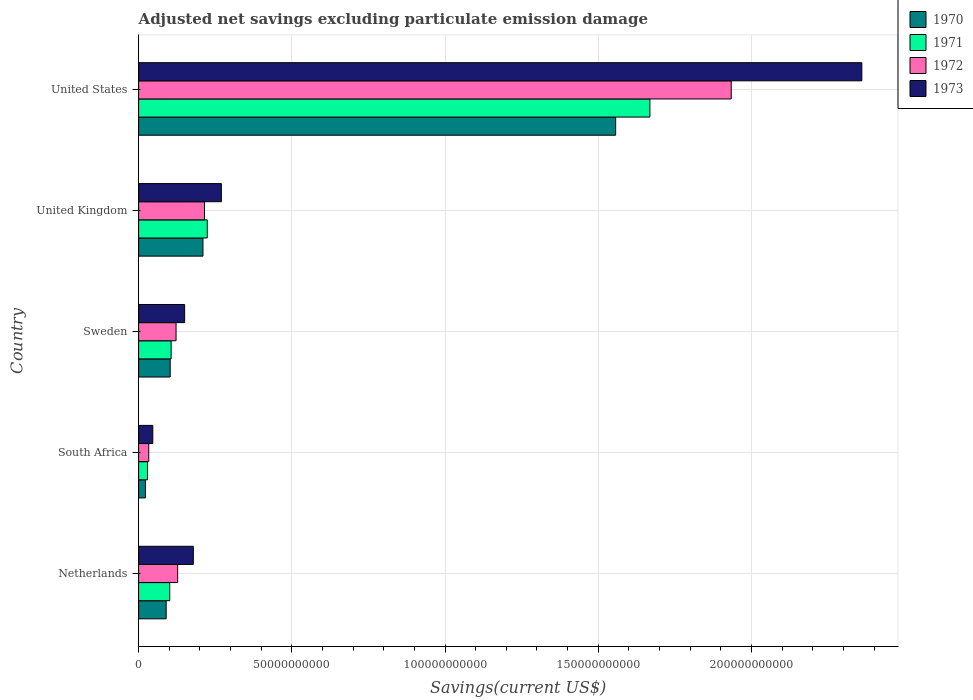How many groups of bars are there?
Ensure brevity in your answer.  5. Are the number of bars per tick equal to the number of legend labels?
Give a very brief answer. Yes. How many bars are there on the 5th tick from the top?
Ensure brevity in your answer.  4. In how many cases, is the number of bars for a given country not equal to the number of legend labels?
Your answer should be compact. 0. What is the adjusted net savings in 1973 in United States?
Offer a very short reply. 2.36e+11. Across all countries, what is the maximum adjusted net savings in 1972?
Offer a very short reply. 1.93e+11. Across all countries, what is the minimum adjusted net savings in 1970?
Keep it short and to the point. 2.22e+09. In which country was the adjusted net savings in 1971 maximum?
Ensure brevity in your answer.  United States. In which country was the adjusted net savings in 1970 minimum?
Your response must be concise. South Africa. What is the total adjusted net savings in 1972 in the graph?
Keep it short and to the point. 2.43e+11. What is the difference between the adjusted net savings in 1973 in Sweden and that in United States?
Provide a succinct answer. -2.21e+11. What is the difference between the adjusted net savings in 1972 in United Kingdom and the adjusted net savings in 1970 in Netherlands?
Your answer should be very brief. 1.25e+1. What is the average adjusted net savings in 1971 per country?
Give a very brief answer. 4.26e+1. What is the difference between the adjusted net savings in 1973 and adjusted net savings in 1971 in Netherlands?
Your response must be concise. 7.70e+09. What is the ratio of the adjusted net savings in 1970 in South Africa to that in Sweden?
Keep it short and to the point. 0.22. Is the difference between the adjusted net savings in 1973 in South Africa and United Kingdom greater than the difference between the adjusted net savings in 1971 in South Africa and United Kingdom?
Your answer should be compact. No. What is the difference between the highest and the second highest adjusted net savings in 1972?
Ensure brevity in your answer.  1.72e+11. What is the difference between the highest and the lowest adjusted net savings in 1972?
Give a very brief answer. 1.90e+11. Is the sum of the adjusted net savings in 1970 in Netherlands and United Kingdom greater than the maximum adjusted net savings in 1972 across all countries?
Your answer should be compact. No. What does the 3rd bar from the top in United Kingdom represents?
Give a very brief answer. 1971. Are all the bars in the graph horizontal?
Provide a short and direct response. Yes. What is the difference between two consecutive major ticks on the X-axis?
Offer a terse response. 5.00e+1. Does the graph contain grids?
Keep it short and to the point. Yes. Where does the legend appear in the graph?
Your response must be concise. Top right. How are the legend labels stacked?
Make the answer very short. Vertical. What is the title of the graph?
Give a very brief answer. Adjusted net savings excluding particulate emission damage. Does "2004" appear as one of the legend labels in the graph?
Your answer should be compact. No. What is the label or title of the X-axis?
Your answer should be very brief. Savings(current US$). What is the label or title of the Y-axis?
Keep it short and to the point. Country. What is the Savings(current US$) in 1970 in Netherlands?
Provide a succinct answer. 8.99e+09. What is the Savings(current US$) of 1971 in Netherlands?
Provide a short and direct response. 1.02e+1. What is the Savings(current US$) in 1972 in Netherlands?
Your answer should be very brief. 1.27e+1. What is the Savings(current US$) in 1973 in Netherlands?
Provide a short and direct response. 1.79e+1. What is the Savings(current US$) in 1970 in South Africa?
Your answer should be compact. 2.22e+09. What is the Savings(current US$) of 1971 in South Africa?
Your answer should be compact. 2.90e+09. What is the Savings(current US$) in 1972 in South Africa?
Provide a short and direct response. 3.30e+09. What is the Savings(current US$) of 1973 in South Africa?
Provide a short and direct response. 4.62e+09. What is the Savings(current US$) in 1970 in Sweden?
Your answer should be very brief. 1.03e+1. What is the Savings(current US$) in 1971 in Sweden?
Provide a succinct answer. 1.06e+1. What is the Savings(current US$) of 1972 in Sweden?
Make the answer very short. 1.22e+1. What is the Savings(current US$) of 1973 in Sweden?
Offer a terse response. 1.50e+1. What is the Savings(current US$) of 1970 in United Kingdom?
Provide a succinct answer. 2.10e+1. What is the Savings(current US$) in 1971 in United Kingdom?
Provide a short and direct response. 2.24e+1. What is the Savings(current US$) of 1972 in United Kingdom?
Your answer should be very brief. 2.15e+1. What is the Savings(current US$) in 1973 in United Kingdom?
Offer a terse response. 2.70e+1. What is the Savings(current US$) of 1970 in United States?
Ensure brevity in your answer.  1.56e+11. What is the Savings(current US$) of 1971 in United States?
Keep it short and to the point. 1.67e+11. What is the Savings(current US$) in 1972 in United States?
Ensure brevity in your answer.  1.93e+11. What is the Savings(current US$) in 1973 in United States?
Offer a terse response. 2.36e+11. Across all countries, what is the maximum Savings(current US$) of 1970?
Provide a short and direct response. 1.56e+11. Across all countries, what is the maximum Savings(current US$) of 1971?
Provide a succinct answer. 1.67e+11. Across all countries, what is the maximum Savings(current US$) in 1972?
Your answer should be very brief. 1.93e+11. Across all countries, what is the maximum Savings(current US$) in 1973?
Offer a terse response. 2.36e+11. Across all countries, what is the minimum Savings(current US$) of 1970?
Your answer should be compact. 2.22e+09. Across all countries, what is the minimum Savings(current US$) of 1971?
Keep it short and to the point. 2.90e+09. Across all countries, what is the minimum Savings(current US$) of 1972?
Make the answer very short. 3.30e+09. Across all countries, what is the minimum Savings(current US$) in 1973?
Offer a terse response. 4.62e+09. What is the total Savings(current US$) in 1970 in the graph?
Your response must be concise. 1.98e+11. What is the total Savings(current US$) in 1971 in the graph?
Keep it short and to the point. 2.13e+11. What is the total Savings(current US$) in 1972 in the graph?
Give a very brief answer. 2.43e+11. What is the total Savings(current US$) in 1973 in the graph?
Give a very brief answer. 3.01e+11. What is the difference between the Savings(current US$) in 1970 in Netherlands and that in South Africa?
Make the answer very short. 6.77e+09. What is the difference between the Savings(current US$) of 1971 in Netherlands and that in South Africa?
Make the answer very short. 7.25e+09. What is the difference between the Savings(current US$) of 1972 in Netherlands and that in South Africa?
Offer a terse response. 9.43e+09. What is the difference between the Savings(current US$) of 1973 in Netherlands and that in South Africa?
Ensure brevity in your answer.  1.32e+1. What is the difference between the Savings(current US$) of 1970 in Netherlands and that in Sweden?
Provide a short and direct response. -1.31e+09. What is the difference between the Savings(current US$) of 1971 in Netherlands and that in Sweden?
Keep it short and to the point. -4.54e+08. What is the difference between the Savings(current US$) in 1972 in Netherlands and that in Sweden?
Provide a succinct answer. 5.20e+08. What is the difference between the Savings(current US$) of 1973 in Netherlands and that in Sweden?
Your answer should be compact. 2.83e+09. What is the difference between the Savings(current US$) in 1970 in Netherlands and that in United Kingdom?
Your answer should be very brief. -1.20e+1. What is the difference between the Savings(current US$) of 1971 in Netherlands and that in United Kingdom?
Ensure brevity in your answer.  -1.22e+1. What is the difference between the Savings(current US$) of 1972 in Netherlands and that in United Kingdom?
Make the answer very short. -8.76e+09. What is the difference between the Savings(current US$) in 1973 in Netherlands and that in United Kingdom?
Ensure brevity in your answer.  -9.15e+09. What is the difference between the Savings(current US$) of 1970 in Netherlands and that in United States?
Provide a short and direct response. -1.47e+11. What is the difference between the Savings(current US$) in 1971 in Netherlands and that in United States?
Offer a terse response. -1.57e+11. What is the difference between the Savings(current US$) in 1972 in Netherlands and that in United States?
Your response must be concise. -1.81e+11. What is the difference between the Savings(current US$) of 1973 in Netherlands and that in United States?
Give a very brief answer. -2.18e+11. What is the difference between the Savings(current US$) in 1970 in South Africa and that in Sweden?
Ensure brevity in your answer.  -8.08e+09. What is the difference between the Savings(current US$) of 1971 in South Africa and that in Sweden?
Offer a very short reply. -7.70e+09. What is the difference between the Savings(current US$) of 1972 in South Africa and that in Sweden?
Your answer should be compact. -8.91e+09. What is the difference between the Savings(current US$) of 1973 in South Africa and that in Sweden?
Offer a very short reply. -1.04e+1. What is the difference between the Savings(current US$) of 1970 in South Africa and that in United Kingdom?
Offer a terse response. -1.88e+1. What is the difference between the Savings(current US$) in 1971 in South Africa and that in United Kingdom?
Ensure brevity in your answer.  -1.95e+1. What is the difference between the Savings(current US$) of 1972 in South Africa and that in United Kingdom?
Keep it short and to the point. -1.82e+1. What is the difference between the Savings(current US$) in 1973 in South Africa and that in United Kingdom?
Your response must be concise. -2.24e+1. What is the difference between the Savings(current US$) in 1970 in South Africa and that in United States?
Provide a short and direct response. -1.53e+11. What is the difference between the Savings(current US$) of 1971 in South Africa and that in United States?
Your answer should be very brief. -1.64e+11. What is the difference between the Savings(current US$) of 1972 in South Africa and that in United States?
Provide a succinct answer. -1.90e+11. What is the difference between the Savings(current US$) in 1973 in South Africa and that in United States?
Give a very brief answer. -2.31e+11. What is the difference between the Savings(current US$) of 1970 in Sweden and that in United Kingdom?
Provide a succinct answer. -1.07e+1. What is the difference between the Savings(current US$) in 1971 in Sweden and that in United Kingdom?
Your answer should be very brief. -1.18e+1. What is the difference between the Savings(current US$) of 1972 in Sweden and that in United Kingdom?
Keep it short and to the point. -9.28e+09. What is the difference between the Savings(current US$) of 1973 in Sweden and that in United Kingdom?
Your answer should be very brief. -1.20e+1. What is the difference between the Savings(current US$) of 1970 in Sweden and that in United States?
Provide a short and direct response. -1.45e+11. What is the difference between the Savings(current US$) of 1971 in Sweden and that in United States?
Your response must be concise. -1.56e+11. What is the difference between the Savings(current US$) in 1972 in Sweden and that in United States?
Your response must be concise. -1.81e+11. What is the difference between the Savings(current US$) in 1973 in Sweden and that in United States?
Provide a succinct answer. -2.21e+11. What is the difference between the Savings(current US$) in 1970 in United Kingdom and that in United States?
Offer a very short reply. -1.35e+11. What is the difference between the Savings(current US$) in 1971 in United Kingdom and that in United States?
Provide a succinct answer. -1.44e+11. What is the difference between the Savings(current US$) in 1972 in United Kingdom and that in United States?
Offer a terse response. -1.72e+11. What is the difference between the Savings(current US$) in 1973 in United Kingdom and that in United States?
Offer a terse response. -2.09e+11. What is the difference between the Savings(current US$) in 1970 in Netherlands and the Savings(current US$) in 1971 in South Africa?
Your answer should be very brief. 6.09e+09. What is the difference between the Savings(current US$) of 1970 in Netherlands and the Savings(current US$) of 1972 in South Africa?
Your answer should be compact. 5.69e+09. What is the difference between the Savings(current US$) of 1970 in Netherlands and the Savings(current US$) of 1973 in South Africa?
Offer a terse response. 4.37e+09. What is the difference between the Savings(current US$) in 1971 in Netherlands and the Savings(current US$) in 1972 in South Africa?
Make the answer very short. 6.85e+09. What is the difference between the Savings(current US$) in 1971 in Netherlands and the Savings(current US$) in 1973 in South Africa?
Ensure brevity in your answer.  5.53e+09. What is the difference between the Savings(current US$) of 1972 in Netherlands and the Savings(current US$) of 1973 in South Africa?
Make the answer very short. 8.11e+09. What is the difference between the Savings(current US$) of 1970 in Netherlands and the Savings(current US$) of 1971 in Sweden?
Your response must be concise. -1.62e+09. What is the difference between the Savings(current US$) of 1970 in Netherlands and the Savings(current US$) of 1972 in Sweden?
Ensure brevity in your answer.  -3.23e+09. What is the difference between the Savings(current US$) of 1970 in Netherlands and the Savings(current US$) of 1973 in Sweden?
Provide a succinct answer. -6.03e+09. What is the difference between the Savings(current US$) in 1971 in Netherlands and the Savings(current US$) in 1972 in Sweden?
Provide a short and direct response. -2.06e+09. What is the difference between the Savings(current US$) in 1971 in Netherlands and the Savings(current US$) in 1973 in Sweden?
Your answer should be compact. -4.86e+09. What is the difference between the Savings(current US$) of 1972 in Netherlands and the Savings(current US$) of 1973 in Sweden?
Offer a very short reply. -2.28e+09. What is the difference between the Savings(current US$) in 1970 in Netherlands and the Savings(current US$) in 1971 in United Kingdom?
Provide a succinct answer. -1.34e+1. What is the difference between the Savings(current US$) in 1970 in Netherlands and the Savings(current US$) in 1972 in United Kingdom?
Keep it short and to the point. -1.25e+1. What is the difference between the Savings(current US$) of 1970 in Netherlands and the Savings(current US$) of 1973 in United Kingdom?
Make the answer very short. -1.80e+1. What is the difference between the Savings(current US$) of 1971 in Netherlands and the Savings(current US$) of 1972 in United Kingdom?
Your response must be concise. -1.13e+1. What is the difference between the Savings(current US$) in 1971 in Netherlands and the Savings(current US$) in 1973 in United Kingdom?
Offer a very short reply. -1.68e+1. What is the difference between the Savings(current US$) of 1972 in Netherlands and the Savings(current US$) of 1973 in United Kingdom?
Offer a very short reply. -1.43e+1. What is the difference between the Savings(current US$) of 1970 in Netherlands and the Savings(current US$) of 1971 in United States?
Keep it short and to the point. -1.58e+11. What is the difference between the Savings(current US$) in 1970 in Netherlands and the Savings(current US$) in 1972 in United States?
Offer a terse response. -1.84e+11. What is the difference between the Savings(current US$) of 1970 in Netherlands and the Savings(current US$) of 1973 in United States?
Your answer should be very brief. -2.27e+11. What is the difference between the Savings(current US$) in 1971 in Netherlands and the Savings(current US$) in 1972 in United States?
Keep it short and to the point. -1.83e+11. What is the difference between the Savings(current US$) in 1971 in Netherlands and the Savings(current US$) in 1973 in United States?
Make the answer very short. -2.26e+11. What is the difference between the Savings(current US$) of 1972 in Netherlands and the Savings(current US$) of 1973 in United States?
Offer a very short reply. -2.23e+11. What is the difference between the Savings(current US$) of 1970 in South Africa and the Savings(current US$) of 1971 in Sweden?
Keep it short and to the point. -8.39e+09. What is the difference between the Savings(current US$) in 1970 in South Africa and the Savings(current US$) in 1972 in Sweden?
Provide a short and direct response. -1.00e+1. What is the difference between the Savings(current US$) of 1970 in South Africa and the Savings(current US$) of 1973 in Sweden?
Give a very brief answer. -1.28e+1. What is the difference between the Savings(current US$) of 1971 in South Africa and the Savings(current US$) of 1972 in Sweden?
Your answer should be compact. -9.31e+09. What is the difference between the Savings(current US$) in 1971 in South Africa and the Savings(current US$) in 1973 in Sweden?
Your answer should be very brief. -1.21e+1. What is the difference between the Savings(current US$) of 1972 in South Africa and the Savings(current US$) of 1973 in Sweden?
Your answer should be very brief. -1.17e+1. What is the difference between the Savings(current US$) of 1970 in South Africa and the Savings(current US$) of 1971 in United Kingdom?
Your answer should be very brief. -2.02e+1. What is the difference between the Savings(current US$) of 1970 in South Africa and the Savings(current US$) of 1972 in United Kingdom?
Your response must be concise. -1.93e+1. What is the difference between the Savings(current US$) in 1970 in South Africa and the Savings(current US$) in 1973 in United Kingdom?
Offer a very short reply. -2.48e+1. What is the difference between the Savings(current US$) in 1971 in South Africa and the Savings(current US$) in 1972 in United Kingdom?
Give a very brief answer. -1.86e+1. What is the difference between the Savings(current US$) of 1971 in South Africa and the Savings(current US$) of 1973 in United Kingdom?
Ensure brevity in your answer.  -2.41e+1. What is the difference between the Savings(current US$) of 1972 in South Africa and the Savings(current US$) of 1973 in United Kingdom?
Offer a terse response. -2.37e+1. What is the difference between the Savings(current US$) of 1970 in South Africa and the Savings(current US$) of 1971 in United States?
Provide a short and direct response. -1.65e+11. What is the difference between the Savings(current US$) of 1970 in South Africa and the Savings(current US$) of 1972 in United States?
Your answer should be compact. -1.91e+11. What is the difference between the Savings(current US$) of 1970 in South Africa and the Savings(current US$) of 1973 in United States?
Offer a very short reply. -2.34e+11. What is the difference between the Savings(current US$) of 1971 in South Africa and the Savings(current US$) of 1972 in United States?
Provide a short and direct response. -1.91e+11. What is the difference between the Savings(current US$) in 1971 in South Africa and the Savings(current US$) in 1973 in United States?
Your answer should be very brief. -2.33e+11. What is the difference between the Savings(current US$) in 1972 in South Africa and the Savings(current US$) in 1973 in United States?
Your answer should be very brief. -2.33e+11. What is the difference between the Savings(current US$) in 1970 in Sweden and the Savings(current US$) in 1971 in United Kingdom?
Offer a terse response. -1.21e+1. What is the difference between the Savings(current US$) of 1970 in Sweden and the Savings(current US$) of 1972 in United Kingdom?
Ensure brevity in your answer.  -1.12e+1. What is the difference between the Savings(current US$) in 1970 in Sweden and the Savings(current US$) in 1973 in United Kingdom?
Ensure brevity in your answer.  -1.67e+1. What is the difference between the Savings(current US$) of 1971 in Sweden and the Savings(current US$) of 1972 in United Kingdom?
Keep it short and to the point. -1.09e+1. What is the difference between the Savings(current US$) of 1971 in Sweden and the Savings(current US$) of 1973 in United Kingdom?
Ensure brevity in your answer.  -1.64e+1. What is the difference between the Savings(current US$) of 1972 in Sweden and the Savings(current US$) of 1973 in United Kingdom?
Your response must be concise. -1.48e+1. What is the difference between the Savings(current US$) of 1970 in Sweden and the Savings(current US$) of 1971 in United States?
Your answer should be compact. -1.57e+11. What is the difference between the Savings(current US$) of 1970 in Sweden and the Savings(current US$) of 1972 in United States?
Make the answer very short. -1.83e+11. What is the difference between the Savings(current US$) of 1970 in Sweden and the Savings(current US$) of 1973 in United States?
Provide a short and direct response. -2.26e+11. What is the difference between the Savings(current US$) of 1971 in Sweden and the Savings(current US$) of 1972 in United States?
Ensure brevity in your answer.  -1.83e+11. What is the difference between the Savings(current US$) in 1971 in Sweden and the Savings(current US$) in 1973 in United States?
Offer a very short reply. -2.25e+11. What is the difference between the Savings(current US$) of 1972 in Sweden and the Savings(current US$) of 1973 in United States?
Ensure brevity in your answer.  -2.24e+11. What is the difference between the Savings(current US$) of 1970 in United Kingdom and the Savings(current US$) of 1971 in United States?
Offer a terse response. -1.46e+11. What is the difference between the Savings(current US$) in 1970 in United Kingdom and the Savings(current US$) in 1972 in United States?
Your response must be concise. -1.72e+11. What is the difference between the Savings(current US$) of 1970 in United Kingdom and the Savings(current US$) of 1973 in United States?
Make the answer very short. -2.15e+11. What is the difference between the Savings(current US$) in 1971 in United Kingdom and the Savings(current US$) in 1972 in United States?
Provide a succinct answer. -1.71e+11. What is the difference between the Savings(current US$) of 1971 in United Kingdom and the Savings(current US$) of 1973 in United States?
Offer a terse response. -2.14e+11. What is the difference between the Savings(current US$) in 1972 in United Kingdom and the Savings(current US$) in 1973 in United States?
Offer a terse response. -2.15e+11. What is the average Savings(current US$) of 1970 per country?
Provide a succinct answer. 3.96e+1. What is the average Savings(current US$) of 1971 per country?
Your response must be concise. 4.26e+1. What is the average Savings(current US$) in 1972 per country?
Provide a short and direct response. 4.86e+1. What is the average Savings(current US$) in 1973 per country?
Your response must be concise. 6.01e+1. What is the difference between the Savings(current US$) in 1970 and Savings(current US$) in 1971 in Netherlands?
Ensure brevity in your answer.  -1.17e+09. What is the difference between the Savings(current US$) in 1970 and Savings(current US$) in 1972 in Netherlands?
Your answer should be compact. -3.75e+09. What is the difference between the Savings(current US$) of 1970 and Savings(current US$) of 1973 in Netherlands?
Offer a terse response. -8.86e+09. What is the difference between the Savings(current US$) of 1971 and Savings(current US$) of 1972 in Netherlands?
Your answer should be very brief. -2.58e+09. What is the difference between the Savings(current US$) of 1971 and Savings(current US$) of 1973 in Netherlands?
Offer a very short reply. -7.70e+09. What is the difference between the Savings(current US$) of 1972 and Savings(current US$) of 1973 in Netherlands?
Provide a succinct answer. -5.11e+09. What is the difference between the Savings(current US$) of 1970 and Savings(current US$) of 1971 in South Africa?
Provide a succinct answer. -6.85e+08. What is the difference between the Savings(current US$) in 1970 and Savings(current US$) in 1972 in South Africa?
Offer a terse response. -1.08e+09. What is the difference between the Savings(current US$) of 1970 and Savings(current US$) of 1973 in South Africa?
Your answer should be very brief. -2.40e+09. What is the difference between the Savings(current US$) in 1971 and Savings(current US$) in 1972 in South Africa?
Make the answer very short. -4.00e+08. What is the difference between the Savings(current US$) of 1971 and Savings(current US$) of 1973 in South Africa?
Ensure brevity in your answer.  -1.72e+09. What is the difference between the Savings(current US$) in 1972 and Savings(current US$) in 1973 in South Africa?
Your answer should be very brief. -1.32e+09. What is the difference between the Savings(current US$) in 1970 and Savings(current US$) in 1971 in Sweden?
Offer a very short reply. -3.10e+08. What is the difference between the Savings(current US$) of 1970 and Savings(current US$) of 1972 in Sweden?
Give a very brief answer. -1.92e+09. What is the difference between the Savings(current US$) of 1970 and Savings(current US$) of 1973 in Sweden?
Give a very brief answer. -4.72e+09. What is the difference between the Savings(current US$) of 1971 and Savings(current US$) of 1972 in Sweden?
Ensure brevity in your answer.  -1.61e+09. What is the difference between the Savings(current US$) of 1971 and Savings(current US$) of 1973 in Sweden?
Offer a very short reply. -4.41e+09. What is the difference between the Savings(current US$) in 1972 and Savings(current US$) in 1973 in Sweden?
Provide a succinct answer. -2.80e+09. What is the difference between the Savings(current US$) in 1970 and Savings(current US$) in 1971 in United Kingdom?
Offer a terse response. -1.41e+09. What is the difference between the Savings(current US$) of 1970 and Savings(current US$) of 1972 in United Kingdom?
Ensure brevity in your answer.  -5.08e+08. What is the difference between the Savings(current US$) of 1970 and Savings(current US$) of 1973 in United Kingdom?
Make the answer very short. -6.01e+09. What is the difference between the Savings(current US$) of 1971 and Savings(current US$) of 1972 in United Kingdom?
Give a very brief answer. 9.03e+08. What is the difference between the Savings(current US$) in 1971 and Savings(current US$) in 1973 in United Kingdom?
Keep it short and to the point. -4.60e+09. What is the difference between the Savings(current US$) in 1972 and Savings(current US$) in 1973 in United Kingdom?
Keep it short and to the point. -5.50e+09. What is the difference between the Savings(current US$) in 1970 and Savings(current US$) in 1971 in United States?
Your response must be concise. -1.12e+1. What is the difference between the Savings(current US$) in 1970 and Savings(current US$) in 1972 in United States?
Offer a terse response. -3.77e+1. What is the difference between the Savings(current US$) of 1970 and Savings(current US$) of 1973 in United States?
Provide a succinct answer. -8.03e+1. What is the difference between the Savings(current US$) in 1971 and Savings(current US$) in 1972 in United States?
Your answer should be compact. -2.65e+1. What is the difference between the Savings(current US$) in 1971 and Savings(current US$) in 1973 in United States?
Your answer should be compact. -6.92e+1. What is the difference between the Savings(current US$) of 1972 and Savings(current US$) of 1973 in United States?
Your answer should be very brief. -4.26e+1. What is the ratio of the Savings(current US$) of 1970 in Netherlands to that in South Africa?
Offer a very short reply. 4.05. What is the ratio of the Savings(current US$) of 1971 in Netherlands to that in South Africa?
Make the answer very short. 3.5. What is the ratio of the Savings(current US$) of 1972 in Netherlands to that in South Africa?
Make the answer very short. 3.86. What is the ratio of the Savings(current US$) in 1973 in Netherlands to that in South Africa?
Your answer should be compact. 3.86. What is the ratio of the Savings(current US$) in 1970 in Netherlands to that in Sweden?
Provide a short and direct response. 0.87. What is the ratio of the Savings(current US$) of 1971 in Netherlands to that in Sweden?
Provide a succinct answer. 0.96. What is the ratio of the Savings(current US$) in 1972 in Netherlands to that in Sweden?
Offer a terse response. 1.04. What is the ratio of the Savings(current US$) in 1973 in Netherlands to that in Sweden?
Provide a short and direct response. 1.19. What is the ratio of the Savings(current US$) in 1970 in Netherlands to that in United Kingdom?
Keep it short and to the point. 0.43. What is the ratio of the Savings(current US$) in 1971 in Netherlands to that in United Kingdom?
Make the answer very short. 0.45. What is the ratio of the Savings(current US$) in 1972 in Netherlands to that in United Kingdom?
Provide a succinct answer. 0.59. What is the ratio of the Savings(current US$) in 1973 in Netherlands to that in United Kingdom?
Your response must be concise. 0.66. What is the ratio of the Savings(current US$) in 1970 in Netherlands to that in United States?
Ensure brevity in your answer.  0.06. What is the ratio of the Savings(current US$) in 1971 in Netherlands to that in United States?
Make the answer very short. 0.06. What is the ratio of the Savings(current US$) of 1972 in Netherlands to that in United States?
Give a very brief answer. 0.07. What is the ratio of the Savings(current US$) in 1973 in Netherlands to that in United States?
Give a very brief answer. 0.08. What is the ratio of the Savings(current US$) in 1970 in South Africa to that in Sweden?
Your response must be concise. 0.22. What is the ratio of the Savings(current US$) of 1971 in South Africa to that in Sweden?
Keep it short and to the point. 0.27. What is the ratio of the Savings(current US$) of 1972 in South Africa to that in Sweden?
Your response must be concise. 0.27. What is the ratio of the Savings(current US$) of 1973 in South Africa to that in Sweden?
Your answer should be very brief. 0.31. What is the ratio of the Savings(current US$) of 1970 in South Africa to that in United Kingdom?
Give a very brief answer. 0.11. What is the ratio of the Savings(current US$) of 1971 in South Africa to that in United Kingdom?
Offer a terse response. 0.13. What is the ratio of the Savings(current US$) of 1972 in South Africa to that in United Kingdom?
Give a very brief answer. 0.15. What is the ratio of the Savings(current US$) in 1973 in South Africa to that in United Kingdom?
Make the answer very short. 0.17. What is the ratio of the Savings(current US$) in 1970 in South Africa to that in United States?
Give a very brief answer. 0.01. What is the ratio of the Savings(current US$) of 1971 in South Africa to that in United States?
Ensure brevity in your answer.  0.02. What is the ratio of the Savings(current US$) of 1972 in South Africa to that in United States?
Make the answer very short. 0.02. What is the ratio of the Savings(current US$) of 1973 in South Africa to that in United States?
Your answer should be compact. 0.02. What is the ratio of the Savings(current US$) in 1970 in Sweden to that in United Kingdom?
Offer a very short reply. 0.49. What is the ratio of the Savings(current US$) in 1971 in Sweden to that in United Kingdom?
Give a very brief answer. 0.47. What is the ratio of the Savings(current US$) in 1972 in Sweden to that in United Kingdom?
Provide a succinct answer. 0.57. What is the ratio of the Savings(current US$) of 1973 in Sweden to that in United Kingdom?
Keep it short and to the point. 0.56. What is the ratio of the Savings(current US$) of 1970 in Sweden to that in United States?
Provide a succinct answer. 0.07. What is the ratio of the Savings(current US$) in 1971 in Sweden to that in United States?
Your response must be concise. 0.06. What is the ratio of the Savings(current US$) in 1972 in Sweden to that in United States?
Make the answer very short. 0.06. What is the ratio of the Savings(current US$) in 1973 in Sweden to that in United States?
Offer a terse response. 0.06. What is the ratio of the Savings(current US$) of 1970 in United Kingdom to that in United States?
Your response must be concise. 0.13. What is the ratio of the Savings(current US$) of 1971 in United Kingdom to that in United States?
Ensure brevity in your answer.  0.13. What is the ratio of the Savings(current US$) in 1972 in United Kingdom to that in United States?
Your answer should be very brief. 0.11. What is the ratio of the Savings(current US$) in 1973 in United Kingdom to that in United States?
Ensure brevity in your answer.  0.11. What is the difference between the highest and the second highest Savings(current US$) in 1970?
Make the answer very short. 1.35e+11. What is the difference between the highest and the second highest Savings(current US$) of 1971?
Offer a terse response. 1.44e+11. What is the difference between the highest and the second highest Savings(current US$) in 1972?
Offer a very short reply. 1.72e+11. What is the difference between the highest and the second highest Savings(current US$) in 1973?
Provide a short and direct response. 2.09e+11. What is the difference between the highest and the lowest Savings(current US$) of 1970?
Make the answer very short. 1.53e+11. What is the difference between the highest and the lowest Savings(current US$) of 1971?
Provide a succinct answer. 1.64e+11. What is the difference between the highest and the lowest Savings(current US$) of 1972?
Ensure brevity in your answer.  1.90e+11. What is the difference between the highest and the lowest Savings(current US$) in 1973?
Make the answer very short. 2.31e+11. 